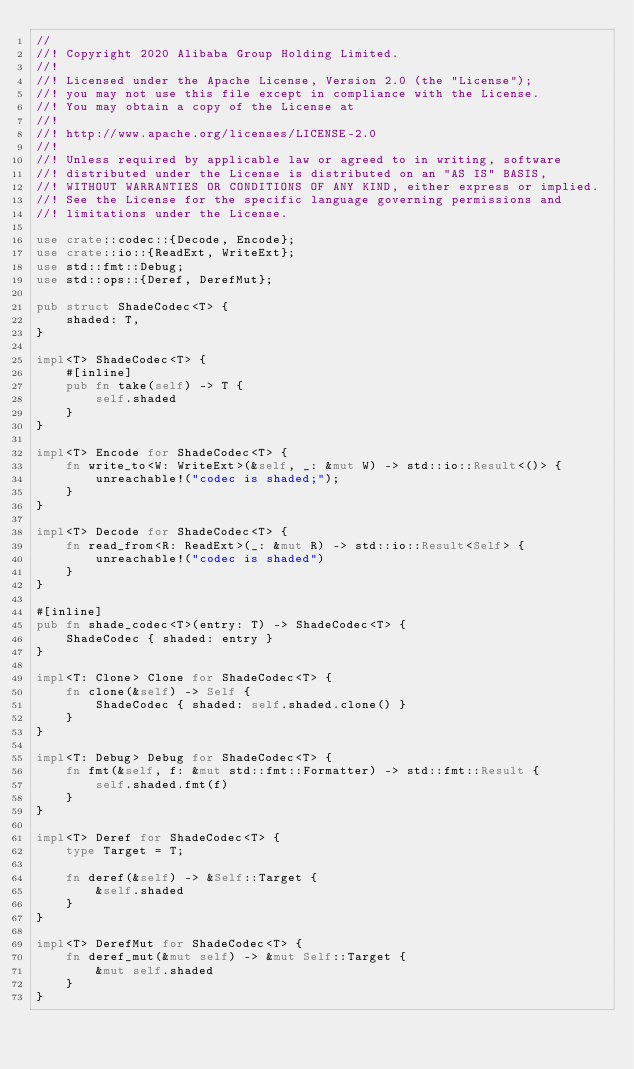Convert code to text. <code><loc_0><loc_0><loc_500><loc_500><_Rust_>//
//! Copyright 2020 Alibaba Group Holding Limited.
//! 
//! Licensed under the Apache License, Version 2.0 (the "License");
//! you may not use this file except in compliance with the License.
//! You may obtain a copy of the License at
//! 
//! http://www.apache.org/licenses/LICENSE-2.0
//! 
//! Unless required by applicable law or agreed to in writing, software
//! distributed under the License is distributed on an "AS IS" BASIS,
//! WITHOUT WARRANTIES OR CONDITIONS OF ANY KIND, either express or implied.
//! See the License for the specific language governing permissions and
//! limitations under the License.

use crate::codec::{Decode, Encode};
use crate::io::{ReadExt, WriteExt};
use std::fmt::Debug;
use std::ops::{Deref, DerefMut};

pub struct ShadeCodec<T> {
    shaded: T,
}

impl<T> ShadeCodec<T> {
    #[inline]
    pub fn take(self) -> T {
        self.shaded
    }
}

impl<T> Encode for ShadeCodec<T> {
    fn write_to<W: WriteExt>(&self, _: &mut W) -> std::io::Result<()> {
        unreachable!("codec is shaded;");
    }
}

impl<T> Decode for ShadeCodec<T> {
    fn read_from<R: ReadExt>(_: &mut R) -> std::io::Result<Self> {
        unreachable!("codec is shaded")
    }
}

#[inline]
pub fn shade_codec<T>(entry: T) -> ShadeCodec<T> {
    ShadeCodec { shaded: entry }
}

impl<T: Clone> Clone for ShadeCodec<T> {
    fn clone(&self) -> Self {
        ShadeCodec { shaded: self.shaded.clone() }
    }
}

impl<T: Debug> Debug for ShadeCodec<T> {
    fn fmt(&self, f: &mut std::fmt::Formatter) -> std::fmt::Result {
        self.shaded.fmt(f)
    }
}

impl<T> Deref for ShadeCodec<T> {
    type Target = T;

    fn deref(&self) -> &Self::Target {
        &self.shaded
    }
}

impl<T> DerefMut for ShadeCodec<T> {
    fn deref_mut(&mut self) -> &mut Self::Target {
        &mut self.shaded
    }
}
</code> 